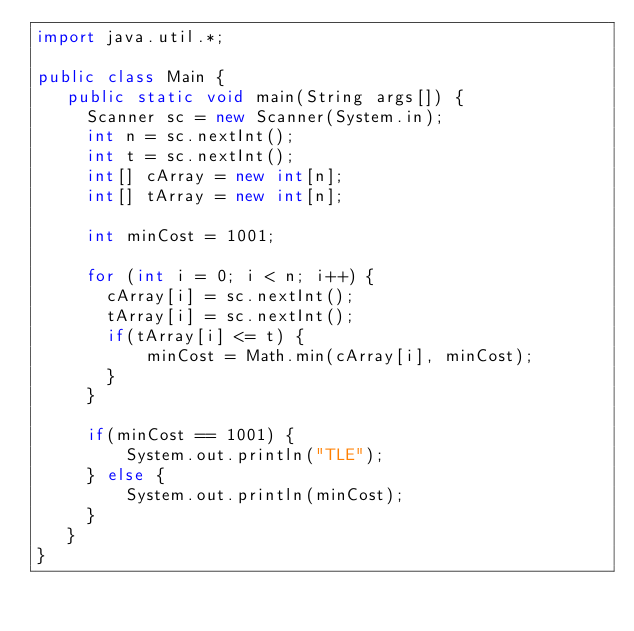<code> <loc_0><loc_0><loc_500><loc_500><_Java_>import java.util.*;

public class Main {
   public static void main(String args[]) {
     Scanner sc = new Scanner(System.in);
     int n = sc.nextInt();
     int t = sc.nextInt();
     int[] cArray = new int[n];
     int[] tArray = new int[n];
     
     int minCost = 1001;
     
     for (int i = 0; i < n; i++) {
       cArray[i] = sc.nextInt();
       tArray[i] = sc.nextInt();
       if(tArray[i] <= t) {
           minCost = Math.min(cArray[i], minCost);
       }
     }
     
     if(minCost == 1001) {
         System.out.println("TLE");
     } else {
         System.out.println(minCost);
     }
   }
}</code> 